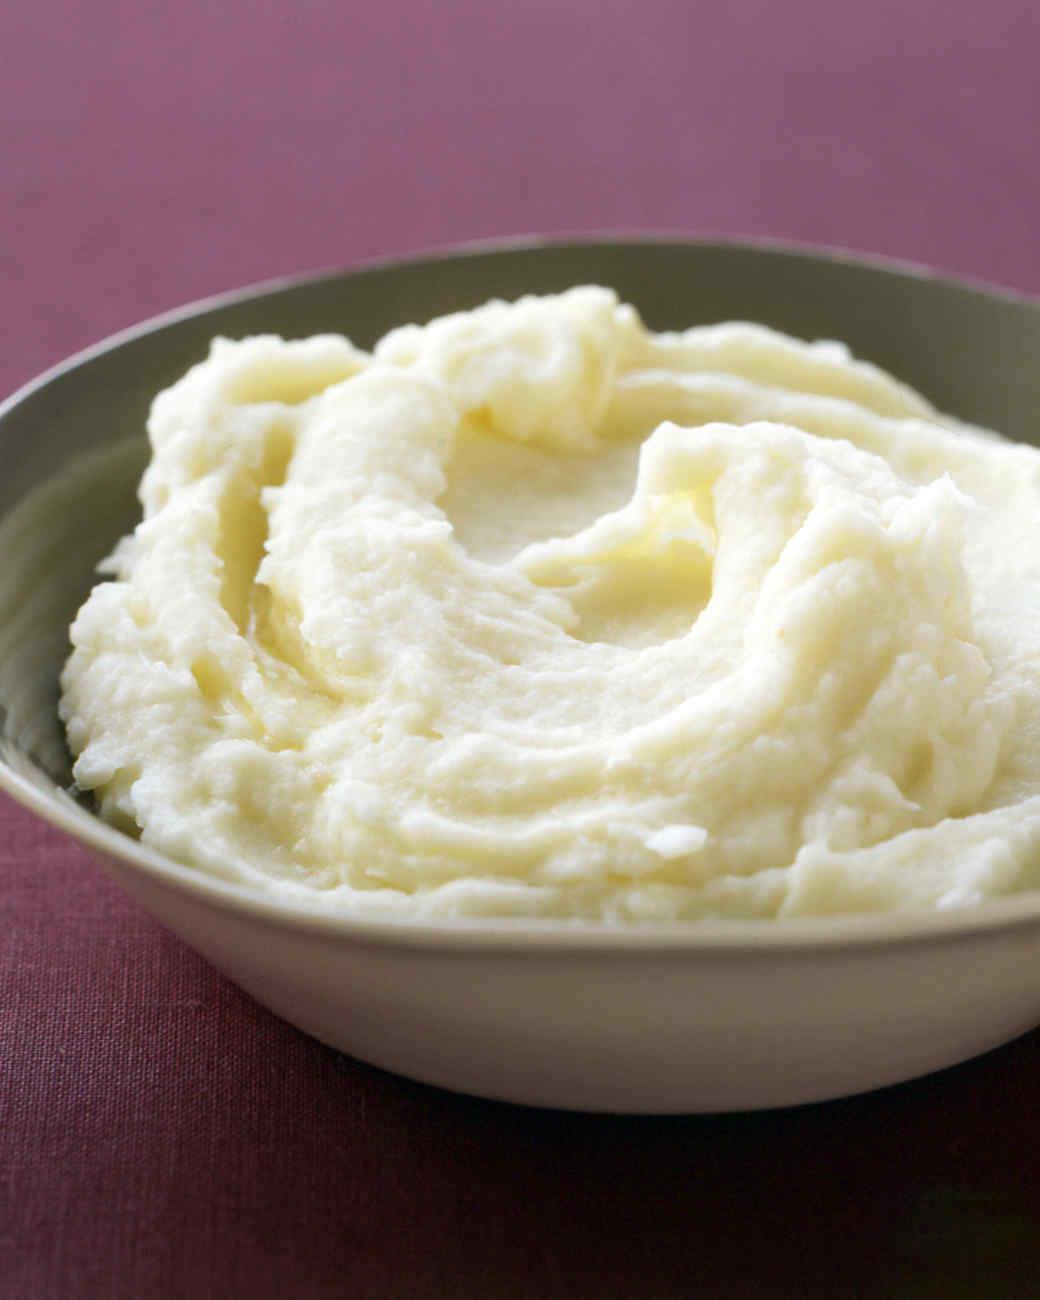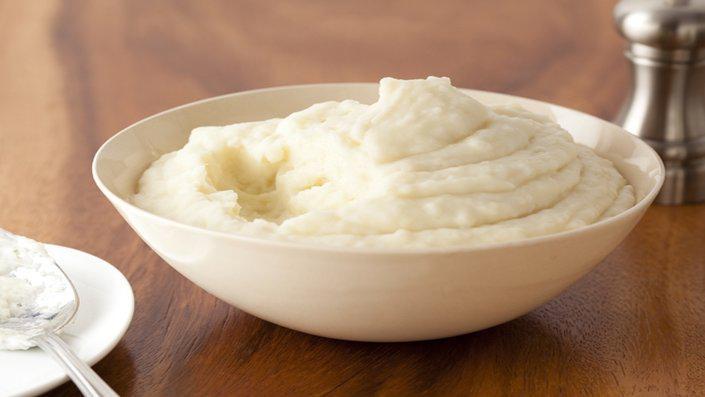The first image is the image on the left, the second image is the image on the right. For the images displayed, is the sentence "A spoon is visible next to one of the dishes of food." factually correct? Answer yes or no. Yes. 